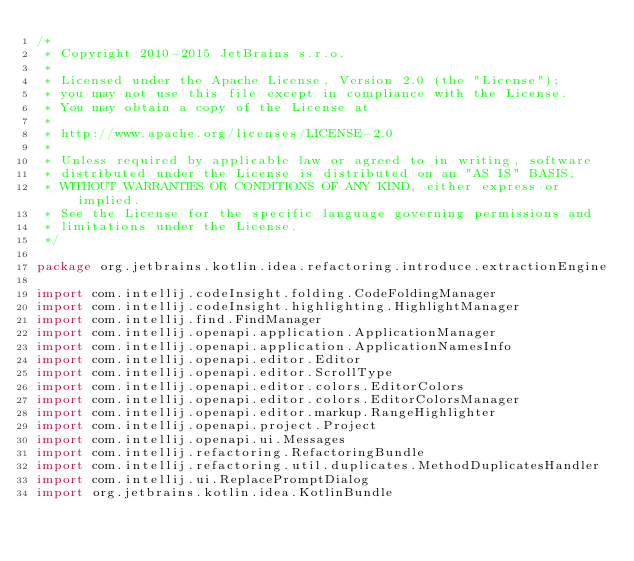Convert code to text. <code><loc_0><loc_0><loc_500><loc_500><_Kotlin_>/*
 * Copyright 2010-2015 JetBrains s.r.o.
 *
 * Licensed under the Apache License, Version 2.0 (the "License");
 * you may not use this file except in compliance with the License.
 * You may obtain a copy of the License at
 *
 * http://www.apache.org/licenses/LICENSE-2.0
 *
 * Unless required by applicable law or agreed to in writing, software
 * distributed under the License is distributed on an "AS IS" BASIS,
 * WITHOUT WARRANTIES OR CONDITIONS OF ANY KIND, either express or implied.
 * See the License for the specific language governing permissions and
 * limitations under the License.
 */

package org.jetbrains.kotlin.idea.refactoring.introduce.extractionEngine

import com.intellij.codeInsight.folding.CodeFoldingManager
import com.intellij.codeInsight.highlighting.HighlightManager
import com.intellij.find.FindManager
import com.intellij.openapi.application.ApplicationManager
import com.intellij.openapi.application.ApplicationNamesInfo
import com.intellij.openapi.editor.Editor
import com.intellij.openapi.editor.ScrollType
import com.intellij.openapi.editor.colors.EditorColors
import com.intellij.openapi.editor.colors.EditorColorsManager
import com.intellij.openapi.editor.markup.RangeHighlighter
import com.intellij.openapi.project.Project
import com.intellij.openapi.ui.Messages
import com.intellij.refactoring.RefactoringBundle
import com.intellij.refactoring.util.duplicates.MethodDuplicatesHandler
import com.intellij.ui.ReplacePromptDialog
import org.jetbrains.kotlin.idea.KotlinBundle</code> 